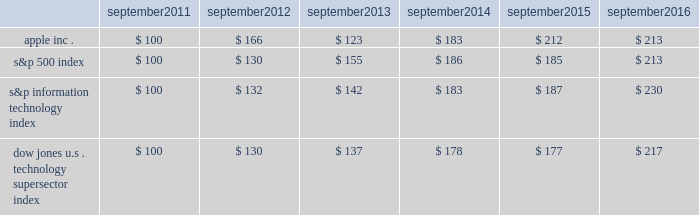Apple inc .
| 2016 form 10-k | 20 company stock performance the following graph shows a comparison of cumulative total shareholder return , calculated on a dividend reinvested basis , for the company , the s&p 500 index , the s&p information technology index and the dow jones u.s .
Technology supersector index for the five years ended september 24 , 2016 .
The graph assumes $ 100 was invested in each of the company 2019s common stock , the s&p 500 index , the s&p information technology index and the dow jones u.s .
Technology supersector index as of the market close on september 23 , 2011 .
Note that historic stock price performance is not necessarily indicative of future stock price performance .
* $ 100 invested on 9/23/11 in stock or index , including reinvestment of dividends .
Data points are the last day of each fiscal year for the company 2019s common stock and september 30th for indexes .
Copyright a9 2016 s&p , a division of mcgraw hill financial .
All rights reserved .
Copyright a9 2016 dow jones & co .
All rights reserved .
September september september september september september .

What is the 6 year return of the dow jones u.s . technology supersector index? 
Computations: ((217 - 100) / 100)
Answer: 1.17. 